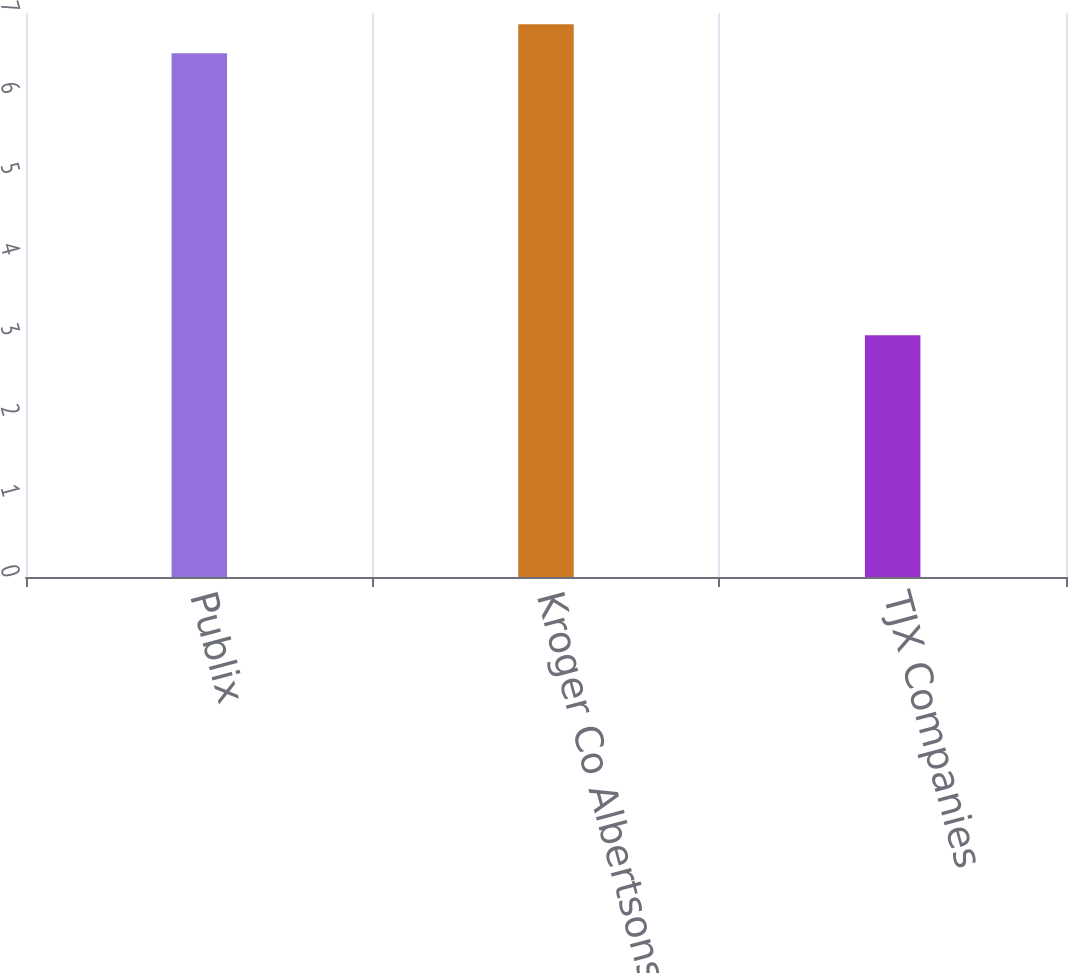<chart> <loc_0><loc_0><loc_500><loc_500><bar_chart><fcel>Publix<fcel>Kroger Co Albertsons Companies<fcel>TJX Companies<nl><fcel>6.5<fcel>6.86<fcel>3<nl></chart> 